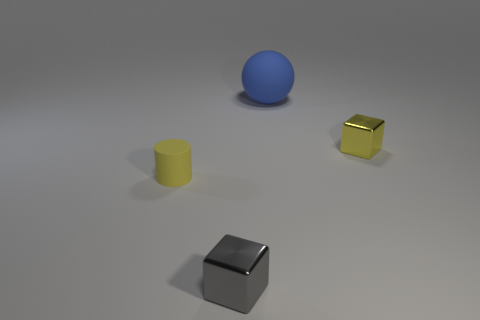What materials do the objects seem to be made of? The sphere has a matte finish, suggesting it could be made of rubber or plastic. The yellow cylinder has a similar matte finish, while the gold cube has a metallic sheen, indicating it could be made of metal. The silver cube also has a reflective metallic surface, which might be stainless steel or polished aluminum. 